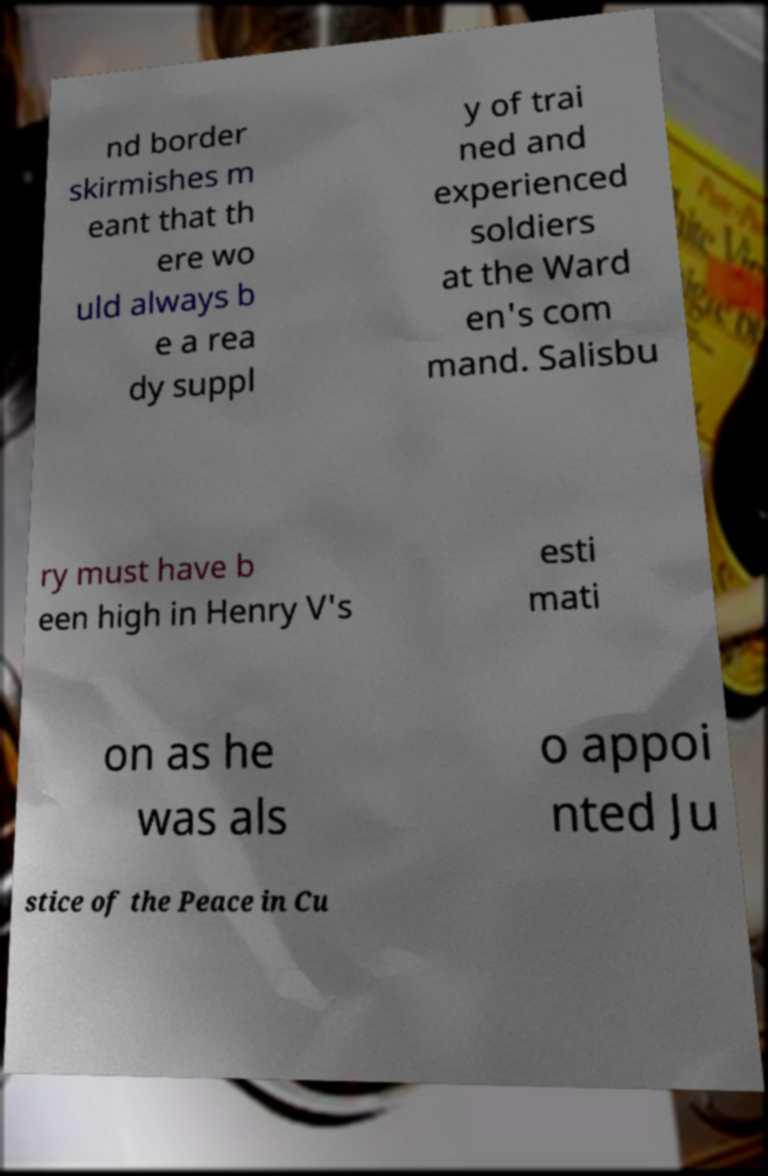What messages or text are displayed in this image? I need them in a readable, typed format. nd border skirmishes m eant that th ere wo uld always b e a rea dy suppl y of trai ned and experienced soldiers at the Ward en's com mand. Salisbu ry must have b een high in Henry V's esti mati on as he was als o appoi nted Ju stice of the Peace in Cu 